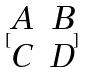Convert formula to latex. <formula><loc_0><loc_0><loc_500><loc_500>[ \begin{matrix} A & B \\ C & D \\ \end{matrix} ]</formula> 